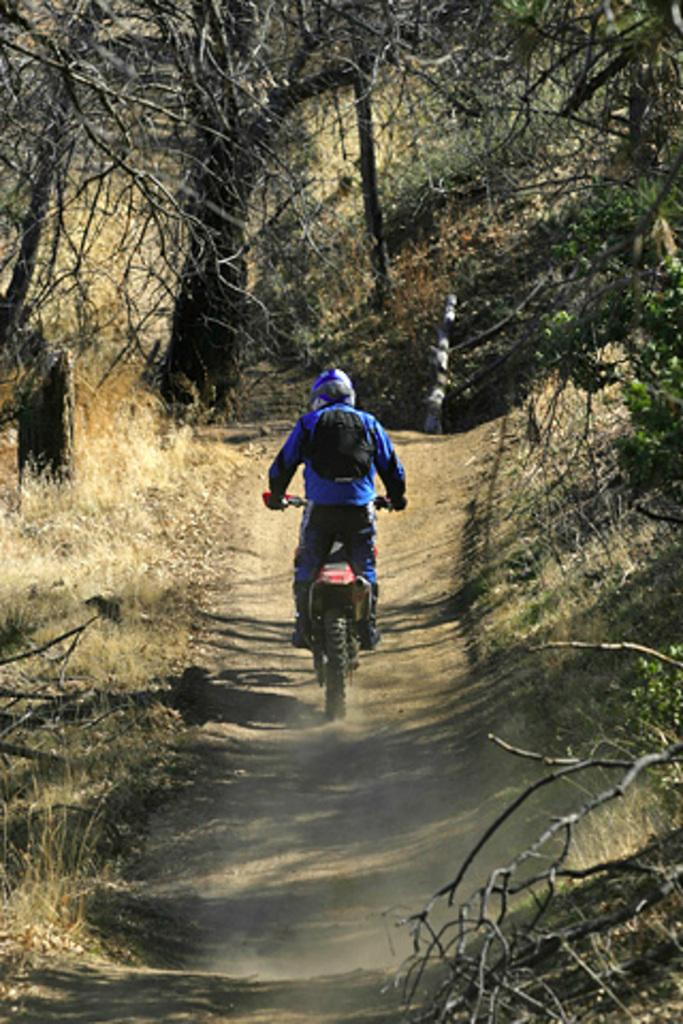What is the person in the image doing? The person is riding a bike in the image. What safety precaution is the person taking while riding the bike? The person is wearing a helmet. What else is the person carrying while riding the bike? The person is carrying a bag. What type of environment is visible in the image? There is grass, trees, and wooden objects visible in the image. How many eyes can be seen on the wooden objects in the image? There are no eyes visible on the wooden objects in the image, as they are inanimate objects and do not have eyes. 